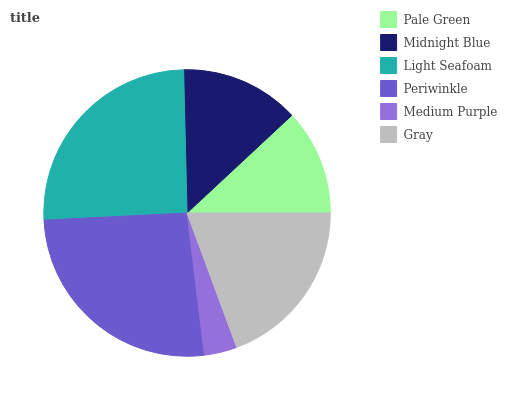Is Medium Purple the minimum?
Answer yes or no. Yes. Is Periwinkle the maximum?
Answer yes or no. Yes. Is Midnight Blue the minimum?
Answer yes or no. No. Is Midnight Blue the maximum?
Answer yes or no. No. Is Midnight Blue greater than Pale Green?
Answer yes or no. Yes. Is Pale Green less than Midnight Blue?
Answer yes or no. Yes. Is Pale Green greater than Midnight Blue?
Answer yes or no. No. Is Midnight Blue less than Pale Green?
Answer yes or no. No. Is Gray the high median?
Answer yes or no. Yes. Is Midnight Blue the low median?
Answer yes or no. Yes. Is Periwinkle the high median?
Answer yes or no. No. Is Light Seafoam the low median?
Answer yes or no. No. 